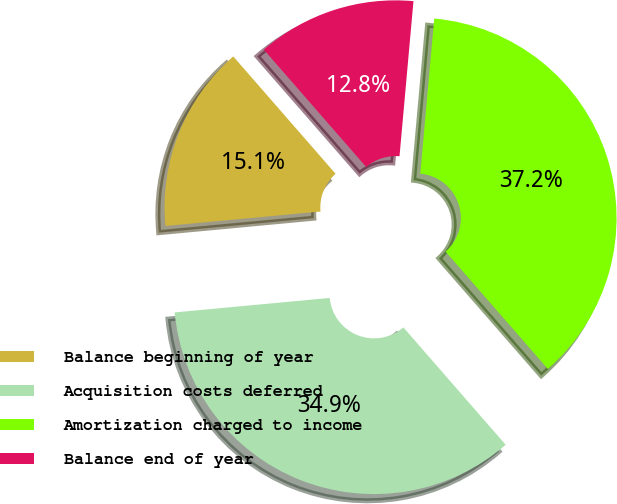Convert chart. <chart><loc_0><loc_0><loc_500><loc_500><pie_chart><fcel>Balance beginning of year<fcel>Acquisition costs deferred<fcel>Amortization charged to income<fcel>Balance end of year<nl><fcel>15.07%<fcel>34.93%<fcel>37.16%<fcel>12.84%<nl></chart> 